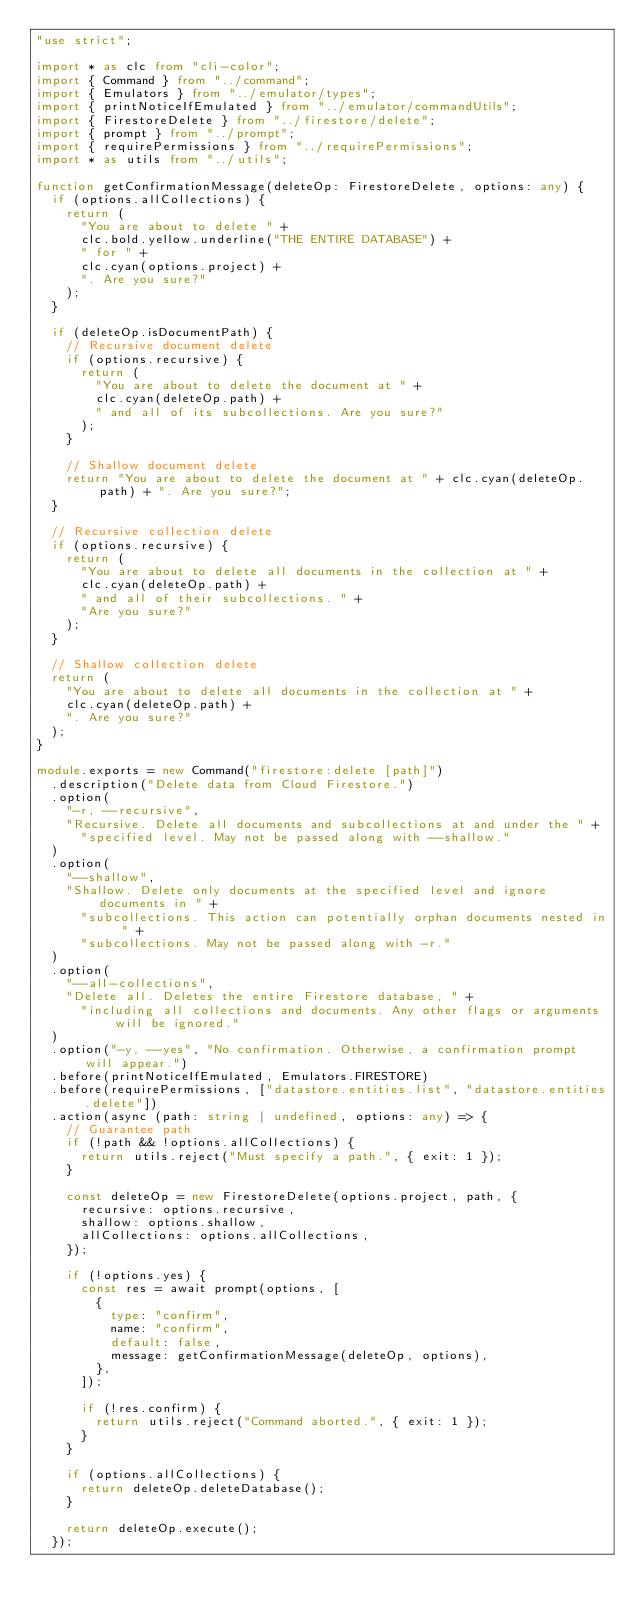Convert code to text. <code><loc_0><loc_0><loc_500><loc_500><_TypeScript_>"use strict";

import * as clc from "cli-color";
import { Command } from "../command";
import { Emulators } from "../emulator/types";
import { printNoticeIfEmulated } from "../emulator/commandUtils";
import { FirestoreDelete } from "../firestore/delete";
import { prompt } from "../prompt";
import { requirePermissions } from "../requirePermissions";
import * as utils from "../utils";

function getConfirmationMessage(deleteOp: FirestoreDelete, options: any) {
  if (options.allCollections) {
    return (
      "You are about to delete " +
      clc.bold.yellow.underline("THE ENTIRE DATABASE") +
      " for " +
      clc.cyan(options.project) +
      ". Are you sure?"
    );
  }

  if (deleteOp.isDocumentPath) {
    // Recursive document delete
    if (options.recursive) {
      return (
        "You are about to delete the document at " +
        clc.cyan(deleteOp.path) +
        " and all of its subcollections. Are you sure?"
      );
    }

    // Shallow document delete
    return "You are about to delete the document at " + clc.cyan(deleteOp.path) + ". Are you sure?";
  }

  // Recursive collection delete
  if (options.recursive) {
    return (
      "You are about to delete all documents in the collection at " +
      clc.cyan(deleteOp.path) +
      " and all of their subcollections. " +
      "Are you sure?"
    );
  }

  // Shallow collection delete
  return (
    "You are about to delete all documents in the collection at " +
    clc.cyan(deleteOp.path) +
    ". Are you sure?"
  );
}

module.exports = new Command("firestore:delete [path]")
  .description("Delete data from Cloud Firestore.")
  .option(
    "-r, --recursive",
    "Recursive. Delete all documents and subcollections at and under the " +
      "specified level. May not be passed along with --shallow."
  )
  .option(
    "--shallow",
    "Shallow. Delete only documents at the specified level and ignore documents in " +
      "subcollections. This action can potentially orphan documents nested in " +
      "subcollections. May not be passed along with -r."
  )
  .option(
    "--all-collections",
    "Delete all. Deletes the entire Firestore database, " +
      "including all collections and documents. Any other flags or arguments will be ignored."
  )
  .option("-y, --yes", "No confirmation. Otherwise, a confirmation prompt will appear.")
  .before(printNoticeIfEmulated, Emulators.FIRESTORE)
  .before(requirePermissions, ["datastore.entities.list", "datastore.entities.delete"])
  .action(async (path: string | undefined, options: any) => {
    // Guarantee path
    if (!path && !options.allCollections) {
      return utils.reject("Must specify a path.", { exit: 1 });
    }

    const deleteOp = new FirestoreDelete(options.project, path, {
      recursive: options.recursive,
      shallow: options.shallow,
      allCollections: options.allCollections,
    });

    if (!options.yes) {
      const res = await prompt(options, [
        {
          type: "confirm",
          name: "confirm",
          default: false,
          message: getConfirmationMessage(deleteOp, options),
        },
      ]);

      if (!res.confirm) {
        return utils.reject("Command aborted.", { exit: 1 });
      }
    }

    if (options.allCollections) {
      return deleteOp.deleteDatabase();
    }

    return deleteOp.execute();
  });
</code> 